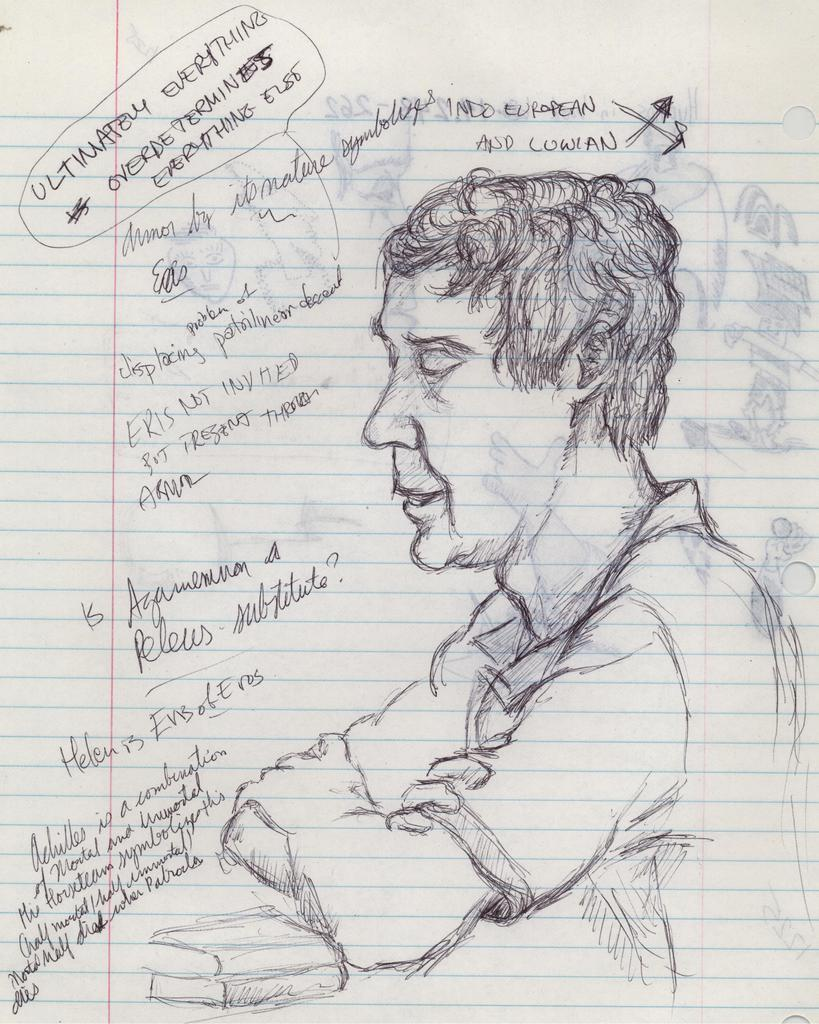What type of paper is visible in the image? There is a ruled paper in the image. What can be seen on the ruled paper? The image contains pencil art. What is the subject of the pencil art? The pencil art depicts a man. What other objects are included in the pencil art? The pencil art includes books. Are there any words in the pencil art? Yes, the pencil art has words on the papers. How many buildings are visible in the pencil art? There are no buildings visible in the pencil art; it depicts a man and books. 